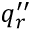Convert formula to latex. <formula><loc_0><loc_0><loc_500><loc_500>q _ { r } ^ { \prime \prime }</formula> 